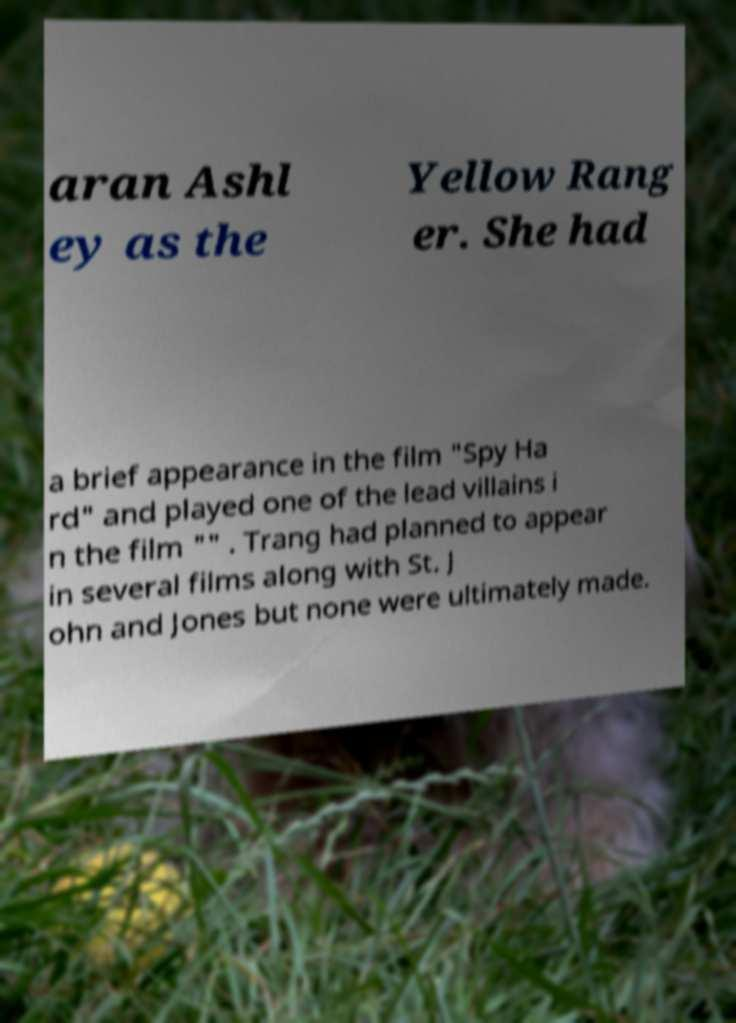I need the written content from this picture converted into text. Can you do that? aran Ashl ey as the Yellow Rang er. She had a brief appearance in the film "Spy Ha rd" and played one of the lead villains i n the film "" . Trang had planned to appear in several films along with St. J ohn and Jones but none were ultimately made. 